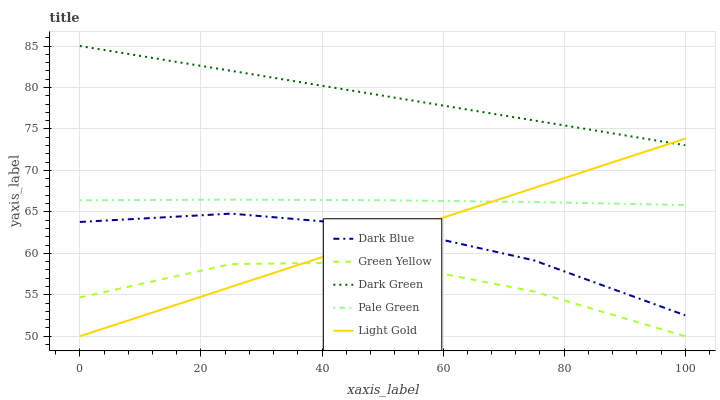Does Green Yellow have the minimum area under the curve?
Answer yes or no. Yes. Does Dark Green have the maximum area under the curve?
Answer yes or no. Yes. Does Pale Green have the minimum area under the curve?
Answer yes or no. No. Does Pale Green have the maximum area under the curve?
Answer yes or no. No. Is Light Gold the smoothest?
Answer yes or no. Yes. Is Green Yellow the roughest?
Answer yes or no. Yes. Is Pale Green the smoothest?
Answer yes or no. No. Is Pale Green the roughest?
Answer yes or no. No. Does Pale Green have the lowest value?
Answer yes or no. No. Does Dark Green have the highest value?
Answer yes or no. Yes. Does Pale Green have the highest value?
Answer yes or no. No. Is Green Yellow less than Pale Green?
Answer yes or no. Yes. Is Dark Blue greater than Green Yellow?
Answer yes or no. Yes. Does Green Yellow intersect Pale Green?
Answer yes or no. No. 